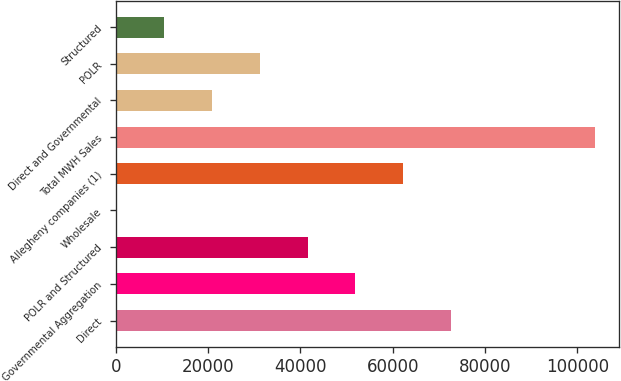Convert chart. <chart><loc_0><loc_0><loc_500><loc_500><bar_chart><fcel>Direct<fcel>Governmental Aggregation<fcel>POLR and Structured<fcel>Wholesale<fcel>Allegheny companies (1)<fcel>Total MWH Sales<fcel>Direct and Governmental<fcel>POLR<fcel>Structured<nl><fcel>72664.3<fcel>51930.5<fcel>41563.6<fcel>96<fcel>62297.4<fcel>103765<fcel>20829.8<fcel>31196.7<fcel>10462.9<nl></chart> 